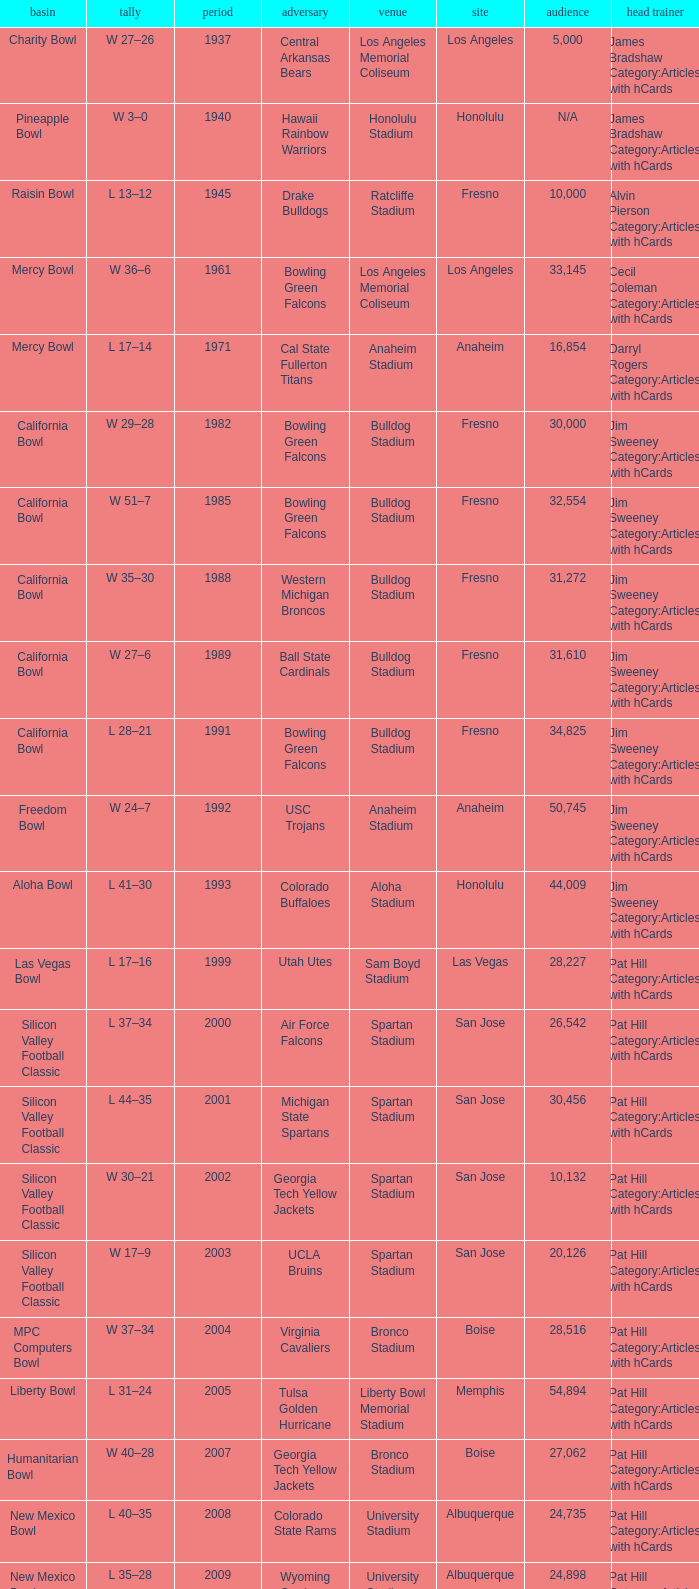What stadium had an opponent of Cal State Fullerton Titans? Anaheim Stadium. 